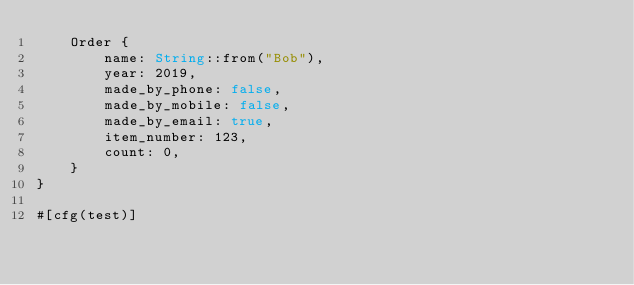<code> <loc_0><loc_0><loc_500><loc_500><_Rust_>    Order {
        name: String::from("Bob"),
        year: 2019,
        made_by_phone: false,
        made_by_mobile: false,
        made_by_email: true,
        item_number: 123,
        count: 0,
    }
}

#[cfg(test)]</code> 